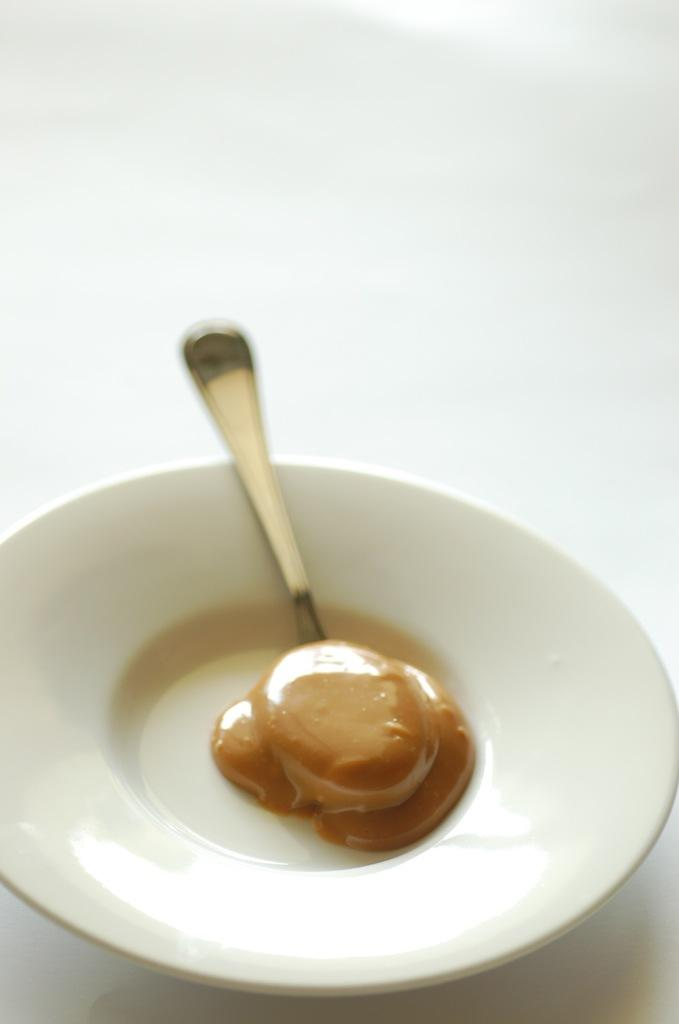What is on the table in the image? There is a plate on the table. What is on the plate? There is food on the plate. What utensil is present near the plate? There is a spoon on the plate or near it. Where is the crowd gathered in the image? There is no crowd present in the image; it only features a plate, food, and a spoon. What type of print can be seen on the plate in the image? There is no print visible on the plate in the image. 